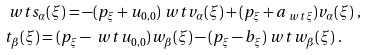Convert formula to latex. <formula><loc_0><loc_0><loc_500><loc_500>& \ w t { s _ { \alpha } ( \xi ) } = - ( p _ { \xi } + u _ { 0 , 0 } ) \ w t { v _ { \alpha } ( \xi ) } + ( p _ { \xi } + a _ { \ w t { \xi } } ) v _ { \alpha } ( \xi ) \ , \\ & { t _ { \beta } ( \xi ) } = ( p _ { \xi } - \ w t { u _ { 0 , 0 } } ) { w _ { \beta } ( \xi ) } - ( p _ { \xi } - b _ { \xi } ) \ w t { w _ { \beta } ( \xi ) } \ .</formula> 